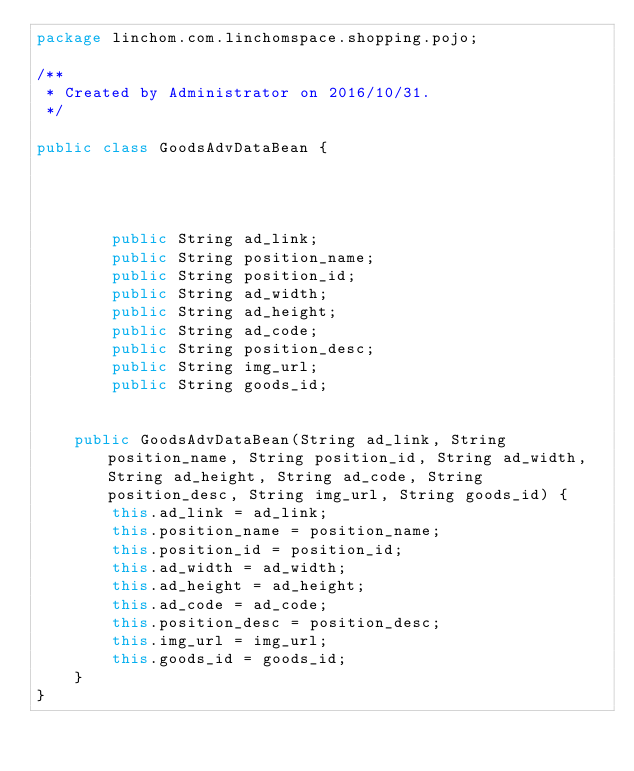<code> <loc_0><loc_0><loc_500><loc_500><_Java_>package linchom.com.linchomspace.shopping.pojo;

/**
 * Created by Administrator on 2016/10/31.
 */

public class GoodsAdvDataBean {




        public String ad_link;
        public String position_name;
        public String position_id;
        public String ad_width;
        public String ad_height;
        public String ad_code;
        public String position_desc;
        public String img_url;
        public String goods_id;


    public GoodsAdvDataBean(String ad_link, String position_name, String position_id, String ad_width, String ad_height, String ad_code, String position_desc, String img_url, String goods_id) {
        this.ad_link = ad_link;
        this.position_name = position_name;
        this.position_id = position_id;
        this.ad_width = ad_width;
        this.ad_height = ad_height;
        this.ad_code = ad_code;
        this.position_desc = position_desc;
        this.img_url = img_url;
        this.goods_id = goods_id;
    }
}
</code> 